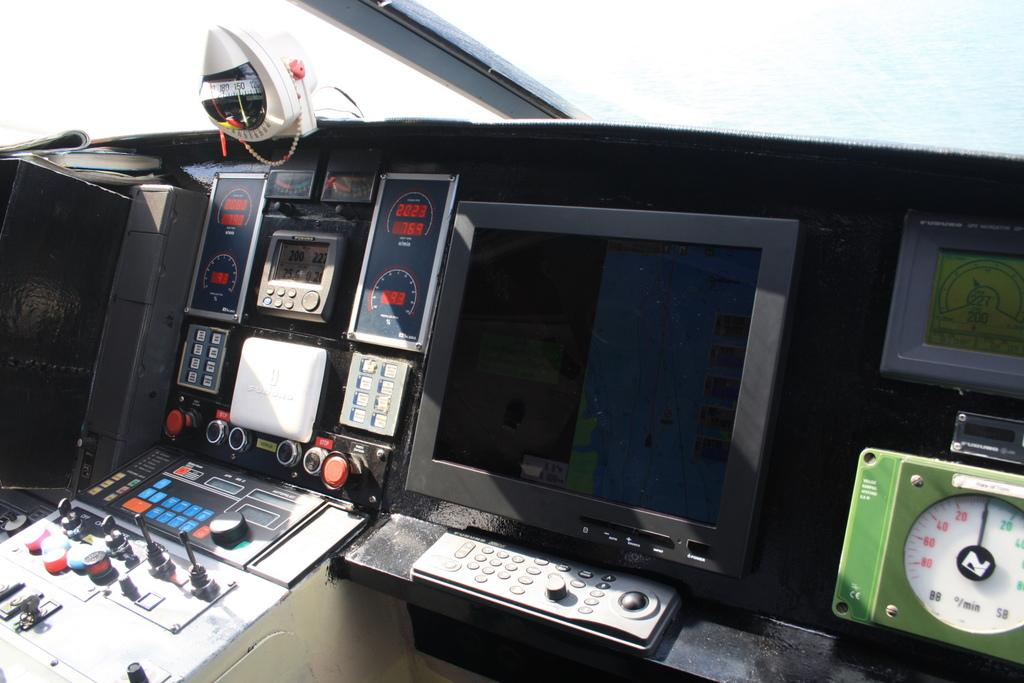What is the main object in the image? There is a screen in the image. What else can be seen in the image besides the screen? There are machines in the image. What color is the background of the image? The background of the image is white. What type of sugar is being used to sweeten the machines in the image? There is no sugar present in the image, and the machines are not being sweetened. 